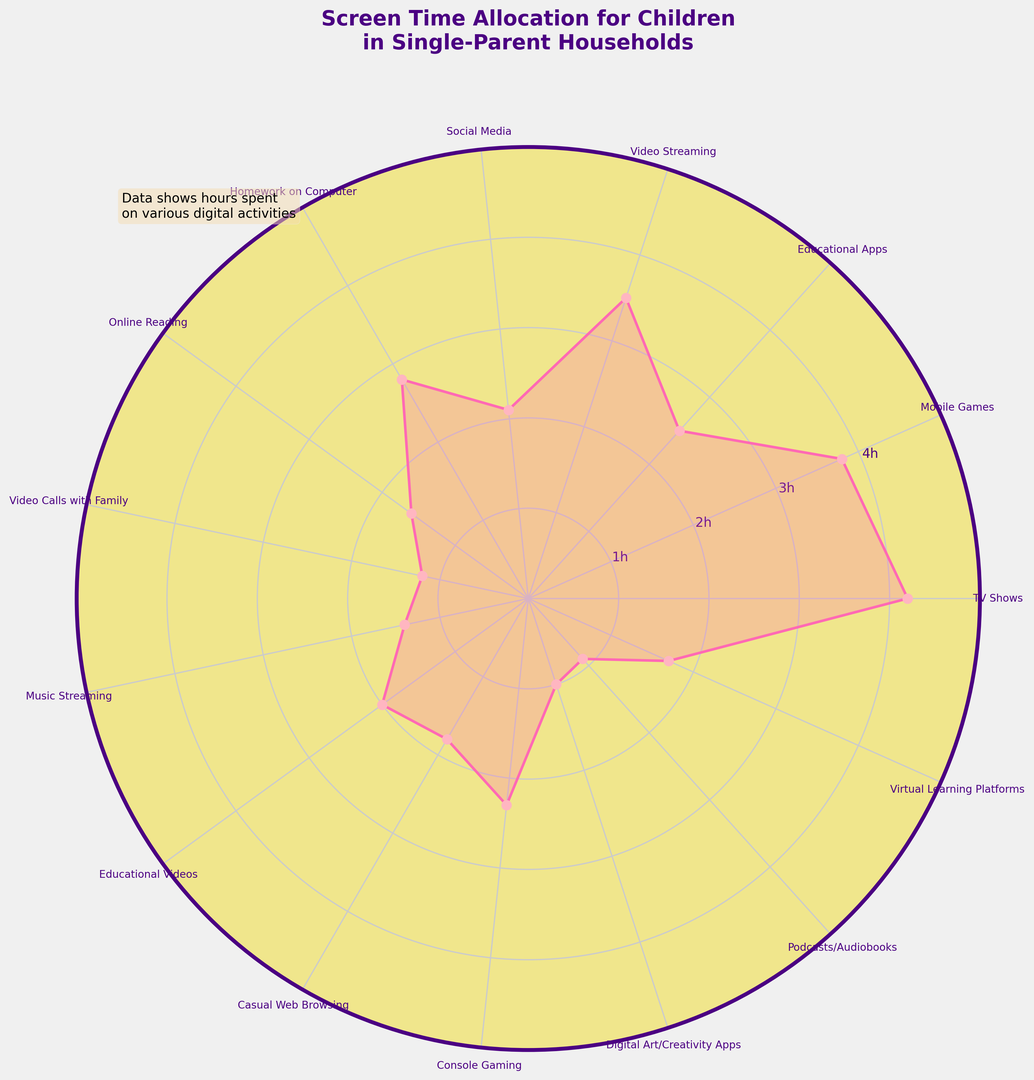What activity has the highest screen time allocation for children in single-parent households? The activity with the highest screen time allocation corresponds to the activity whose segment stretches the farthest from the center on the rose chart.
Answer: TV Shows What two activities have the lowest screen time allocation? The two activities with the smallest segments on the rose chart represent the lowest screen time allocation.
Answer: Podcasts/Audiobooks and Digital Art/Creativity Apps What is the total screen time allocated to educational activities (Educational Apps, Homework on Computer, Educational Videos, Virtual Learning Platforms)? Sum the hours for Educational Apps, Homework on Computer, Educational Videos, and Virtual Learning Platforms, visible as the values for these activities on the rose chart.
Answer: 9 hours Comparing TV Shows and Mobile Games, which one consumes more screen time and by how much? Look at the lengths of the segments for TV Shows and Mobile Games. Subtract the hours allocated to Mobile Games from those allocated to TV Shows.
Answer: TV Shows by 0.4 hours Which activity has a screen time allocation closest to 2 hours? Observe the rose chart and find the segment that reaches closest to the 2-hour mark.
Answer: Educational Videos What is the screen time difference between Social Media and Console Gaming? Identify the hours for Social Media and Console Gaming. Subtract the hours for Social Media from that for Console Gaming.
Answer: Console Gaming by 0.2 hours Considering all activities, what is the average screen time allocation across the activities? Sum the screen time for all activities and divide by the number of activities listed on the rose chart.
Answer: 2.2 hours Is the screen time for Video Streaming greater than that for Homework on Computer? If so, by how much? Compare the lengths of the segments for Video Streaming and Homework on Computer. Subtract the hours for Homework on Computer from those for Video Streaming.
Answer: No, Homework on Computer exceeds by 0.3 hours How does the screen time for Video Calls with Family compare to that for Music Streaming? Compare the segments for Video Calls with Family and Music Streaming. Identify which segment reaches farther from the center.
Answer: Music Streaming by 0.2 hours 